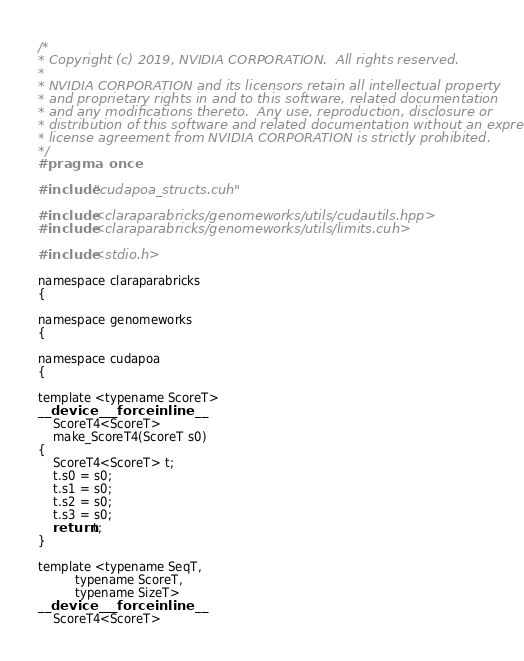Convert code to text. <code><loc_0><loc_0><loc_500><loc_500><_Cuda_>/*
* Copyright (c) 2019, NVIDIA CORPORATION.  All rights reserved.
*
* NVIDIA CORPORATION and its licensors retain all intellectual property
* and proprietary rights in and to this software, related documentation
* and any modifications thereto.  Any use, reproduction, disclosure or
* distribution of this software and related documentation without an express
* license agreement from NVIDIA CORPORATION is strictly prohibited.
*/
#pragma once

#include "cudapoa_structs.cuh"

#include <claraparabricks/genomeworks/utils/cudautils.hpp>
#include <claraparabricks/genomeworks/utils/limits.cuh>

#include <stdio.h>

namespace claraparabricks
{

namespace genomeworks
{

namespace cudapoa
{

template <typename ScoreT>
__device__ __forceinline__
    ScoreT4<ScoreT>
    make_ScoreT4(ScoreT s0)
{
    ScoreT4<ScoreT> t;
    t.s0 = s0;
    t.s1 = s0;
    t.s2 = s0;
    t.s3 = s0;
    return t;
}

template <typename SeqT,
          typename ScoreT,
          typename SizeT>
__device__ __forceinline__
    ScoreT4<ScoreT></code> 